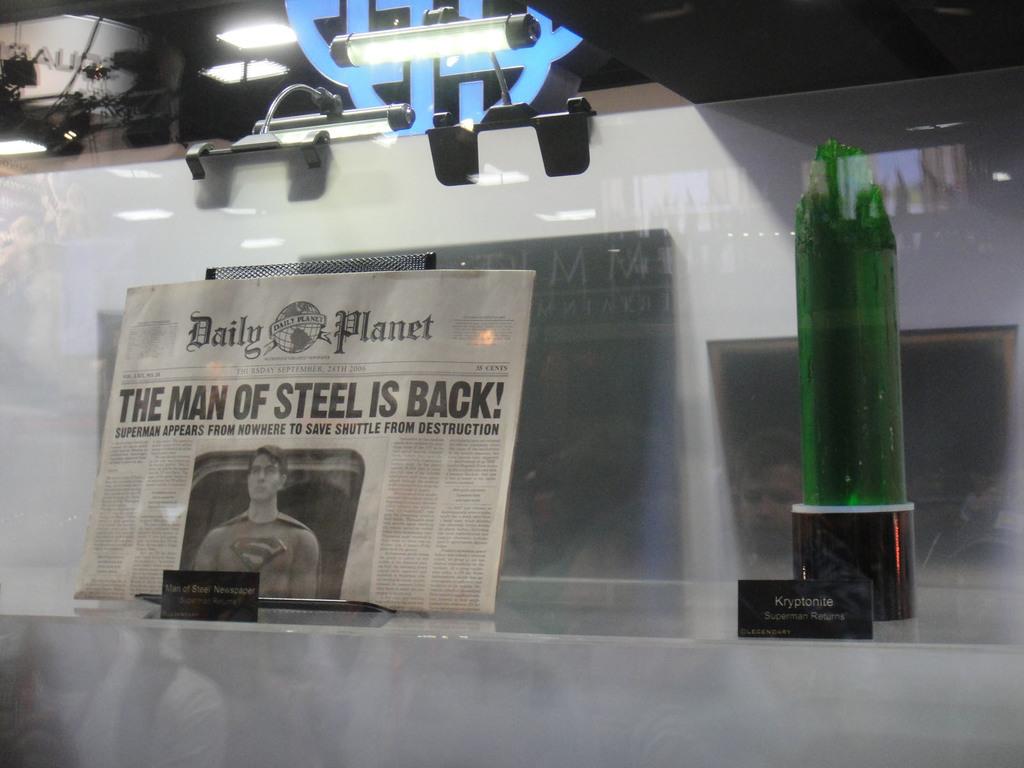Who is the man of steel?
Offer a very short reply. Superman. What is the name of this newspaper?
Give a very brief answer. Daily planet. 